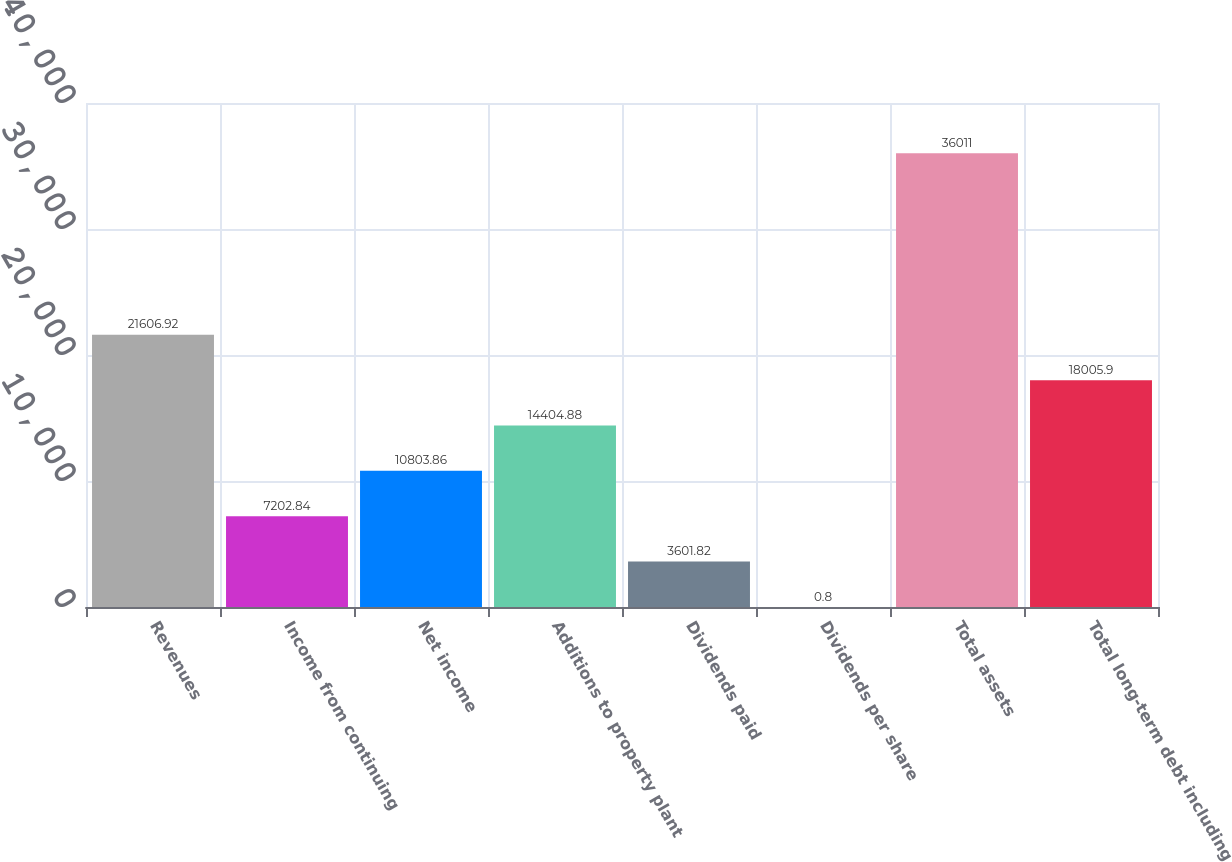Convert chart. <chart><loc_0><loc_0><loc_500><loc_500><bar_chart><fcel>Revenues<fcel>Income from continuing<fcel>Net income<fcel>Additions to property plant<fcel>Dividends paid<fcel>Dividends per share<fcel>Total assets<fcel>Total long-term debt including<nl><fcel>21606.9<fcel>7202.84<fcel>10803.9<fcel>14404.9<fcel>3601.82<fcel>0.8<fcel>36011<fcel>18005.9<nl></chart> 